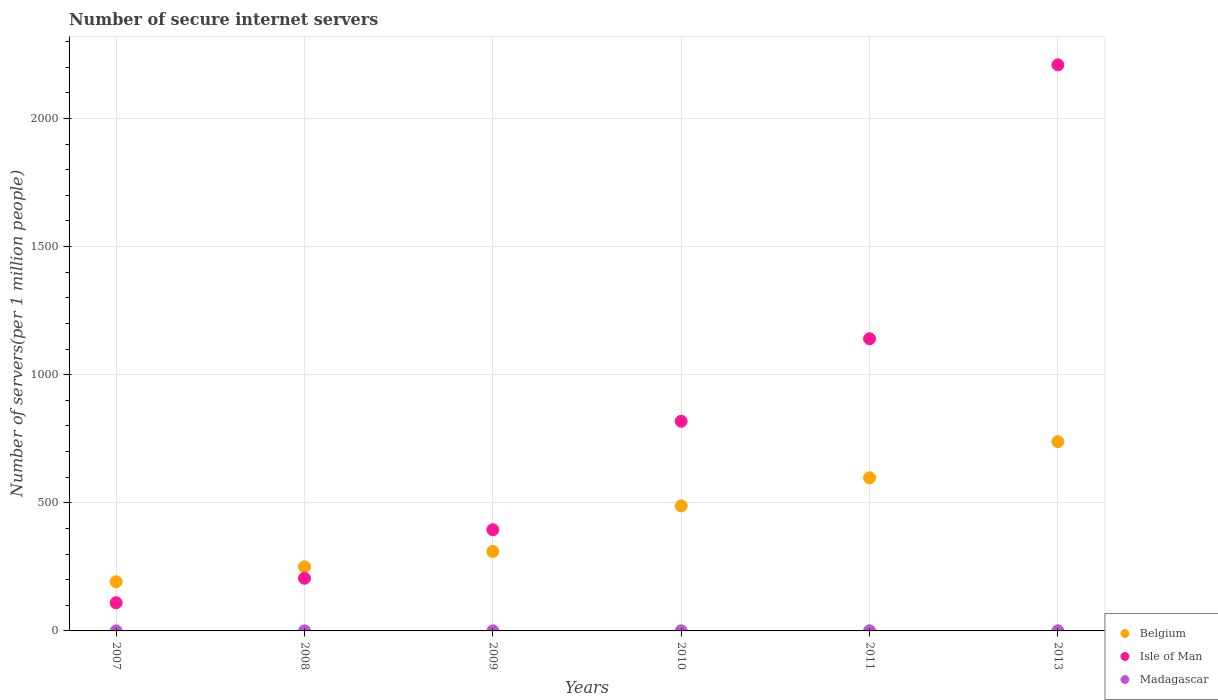Is the number of dotlines equal to the number of legend labels?
Your response must be concise. Yes. What is the number of secure internet servers in Belgium in 2011?
Provide a short and direct response. 597.41. Across all years, what is the maximum number of secure internet servers in Belgium?
Make the answer very short. 738.28. Across all years, what is the minimum number of secure internet servers in Madagascar?
Offer a terse response. 0.2. In which year was the number of secure internet servers in Belgium maximum?
Provide a succinct answer. 2013. What is the total number of secure internet servers in Isle of Man in the graph?
Keep it short and to the point. 4877.88. What is the difference between the number of secure internet servers in Belgium in 2007 and that in 2010?
Provide a succinct answer. -295.91. What is the difference between the number of secure internet servers in Madagascar in 2008 and the number of secure internet servers in Belgium in 2009?
Your answer should be compact. -309.9. What is the average number of secure internet servers in Isle of Man per year?
Give a very brief answer. 812.98. In the year 2008, what is the difference between the number of secure internet servers in Belgium and number of secure internet servers in Isle of Man?
Offer a terse response. 44.58. What is the ratio of the number of secure internet servers in Madagascar in 2008 to that in 2011?
Provide a short and direct response. 0.4. What is the difference between the highest and the second highest number of secure internet servers in Belgium?
Your answer should be very brief. 140.87. What is the difference between the highest and the lowest number of secure internet servers in Madagascar?
Make the answer very short. 0.45. Is the number of secure internet servers in Belgium strictly greater than the number of secure internet servers in Madagascar over the years?
Your response must be concise. Yes. What is the difference between two consecutive major ticks on the Y-axis?
Your answer should be compact. 500. Are the values on the major ticks of Y-axis written in scientific E-notation?
Your response must be concise. No. What is the title of the graph?
Offer a terse response. Number of secure internet servers. What is the label or title of the Y-axis?
Offer a terse response. Number of servers(per 1 million people). What is the Number of servers(per 1 million people) of Belgium in 2007?
Give a very brief answer. 192.08. What is the Number of servers(per 1 million people) in Isle of Man in 2007?
Your answer should be compact. 109.87. What is the Number of servers(per 1 million people) in Madagascar in 2007?
Offer a terse response. 0.21. What is the Number of servers(per 1 million people) of Belgium in 2008?
Offer a very short reply. 250.05. What is the Number of servers(per 1 million people) in Isle of Man in 2008?
Provide a short and direct response. 205.47. What is the Number of servers(per 1 million people) of Madagascar in 2008?
Your response must be concise. 0.2. What is the Number of servers(per 1 million people) in Belgium in 2009?
Give a very brief answer. 310.1. What is the Number of servers(per 1 million people) of Isle of Man in 2009?
Your answer should be very brief. 394.98. What is the Number of servers(per 1 million people) in Madagascar in 2009?
Make the answer very short. 0.39. What is the Number of servers(per 1 million people) in Belgium in 2010?
Your response must be concise. 487.99. What is the Number of servers(per 1 million people) in Isle of Man in 2010?
Your answer should be compact. 818.24. What is the Number of servers(per 1 million people) in Madagascar in 2010?
Your answer should be very brief. 0.47. What is the Number of servers(per 1 million people) in Belgium in 2011?
Your response must be concise. 597.41. What is the Number of servers(per 1 million people) in Isle of Man in 2011?
Keep it short and to the point. 1140.25. What is the Number of servers(per 1 million people) of Madagascar in 2011?
Your answer should be compact. 0.51. What is the Number of servers(per 1 million people) in Belgium in 2013?
Your answer should be compact. 738.28. What is the Number of servers(per 1 million people) in Isle of Man in 2013?
Ensure brevity in your answer.  2209.06. What is the Number of servers(per 1 million people) of Madagascar in 2013?
Your answer should be compact. 0.65. Across all years, what is the maximum Number of servers(per 1 million people) in Belgium?
Give a very brief answer. 738.28. Across all years, what is the maximum Number of servers(per 1 million people) in Isle of Man?
Your answer should be very brief. 2209.06. Across all years, what is the maximum Number of servers(per 1 million people) in Madagascar?
Provide a short and direct response. 0.65. Across all years, what is the minimum Number of servers(per 1 million people) in Belgium?
Provide a short and direct response. 192.08. Across all years, what is the minimum Number of servers(per 1 million people) in Isle of Man?
Offer a terse response. 109.87. Across all years, what is the minimum Number of servers(per 1 million people) in Madagascar?
Give a very brief answer. 0.2. What is the total Number of servers(per 1 million people) in Belgium in the graph?
Provide a short and direct response. 2575.9. What is the total Number of servers(per 1 million people) in Isle of Man in the graph?
Give a very brief answer. 4877.88. What is the total Number of servers(per 1 million people) of Madagascar in the graph?
Keep it short and to the point. 2.43. What is the difference between the Number of servers(per 1 million people) of Belgium in 2007 and that in 2008?
Your answer should be compact. -57.97. What is the difference between the Number of servers(per 1 million people) of Isle of Man in 2007 and that in 2008?
Offer a very short reply. -95.6. What is the difference between the Number of servers(per 1 million people) of Madagascar in 2007 and that in 2008?
Ensure brevity in your answer.  0.01. What is the difference between the Number of servers(per 1 million people) of Belgium in 2007 and that in 2009?
Your answer should be compact. -118.02. What is the difference between the Number of servers(per 1 million people) of Isle of Man in 2007 and that in 2009?
Give a very brief answer. -285.11. What is the difference between the Number of servers(per 1 million people) of Madagascar in 2007 and that in 2009?
Provide a short and direct response. -0.18. What is the difference between the Number of servers(per 1 million people) in Belgium in 2007 and that in 2010?
Provide a short and direct response. -295.91. What is the difference between the Number of servers(per 1 million people) in Isle of Man in 2007 and that in 2010?
Provide a short and direct response. -708.37. What is the difference between the Number of servers(per 1 million people) in Madagascar in 2007 and that in 2010?
Your answer should be compact. -0.27. What is the difference between the Number of servers(per 1 million people) of Belgium in 2007 and that in 2011?
Provide a succinct answer. -405.33. What is the difference between the Number of servers(per 1 million people) of Isle of Man in 2007 and that in 2011?
Make the answer very short. -1030.38. What is the difference between the Number of servers(per 1 million people) of Madagascar in 2007 and that in 2011?
Give a very brief answer. -0.3. What is the difference between the Number of servers(per 1 million people) of Belgium in 2007 and that in 2013?
Keep it short and to the point. -546.19. What is the difference between the Number of servers(per 1 million people) of Isle of Man in 2007 and that in 2013?
Give a very brief answer. -2099.19. What is the difference between the Number of servers(per 1 million people) of Madagascar in 2007 and that in 2013?
Provide a short and direct response. -0.45. What is the difference between the Number of servers(per 1 million people) of Belgium in 2008 and that in 2009?
Ensure brevity in your answer.  -60.05. What is the difference between the Number of servers(per 1 million people) of Isle of Man in 2008 and that in 2009?
Your response must be concise. -189.51. What is the difference between the Number of servers(per 1 million people) in Madagascar in 2008 and that in 2009?
Keep it short and to the point. -0.19. What is the difference between the Number of servers(per 1 million people) in Belgium in 2008 and that in 2010?
Provide a succinct answer. -237.94. What is the difference between the Number of servers(per 1 million people) of Isle of Man in 2008 and that in 2010?
Make the answer very short. -612.77. What is the difference between the Number of servers(per 1 million people) in Madagascar in 2008 and that in 2010?
Offer a very short reply. -0.27. What is the difference between the Number of servers(per 1 million people) of Belgium in 2008 and that in 2011?
Ensure brevity in your answer.  -347.36. What is the difference between the Number of servers(per 1 million people) in Isle of Man in 2008 and that in 2011?
Make the answer very short. -934.78. What is the difference between the Number of servers(per 1 million people) of Madagascar in 2008 and that in 2011?
Your answer should be very brief. -0.31. What is the difference between the Number of servers(per 1 million people) in Belgium in 2008 and that in 2013?
Your response must be concise. -488.23. What is the difference between the Number of servers(per 1 million people) in Isle of Man in 2008 and that in 2013?
Keep it short and to the point. -2003.59. What is the difference between the Number of servers(per 1 million people) of Madagascar in 2008 and that in 2013?
Your answer should be compact. -0.45. What is the difference between the Number of servers(per 1 million people) in Belgium in 2009 and that in 2010?
Provide a short and direct response. -177.89. What is the difference between the Number of servers(per 1 million people) in Isle of Man in 2009 and that in 2010?
Provide a short and direct response. -423.26. What is the difference between the Number of servers(per 1 million people) in Madagascar in 2009 and that in 2010?
Your response must be concise. -0.08. What is the difference between the Number of servers(per 1 million people) in Belgium in 2009 and that in 2011?
Offer a terse response. -287.31. What is the difference between the Number of servers(per 1 million people) in Isle of Man in 2009 and that in 2011?
Provide a succinct answer. -745.27. What is the difference between the Number of servers(per 1 million people) in Madagascar in 2009 and that in 2011?
Offer a terse response. -0.12. What is the difference between the Number of servers(per 1 million people) of Belgium in 2009 and that in 2013?
Your answer should be compact. -428.17. What is the difference between the Number of servers(per 1 million people) in Isle of Man in 2009 and that in 2013?
Keep it short and to the point. -1814.08. What is the difference between the Number of servers(per 1 million people) of Madagascar in 2009 and that in 2013?
Make the answer very short. -0.26. What is the difference between the Number of servers(per 1 million people) of Belgium in 2010 and that in 2011?
Give a very brief answer. -109.42. What is the difference between the Number of servers(per 1 million people) of Isle of Man in 2010 and that in 2011?
Offer a terse response. -322.01. What is the difference between the Number of servers(per 1 million people) in Madagascar in 2010 and that in 2011?
Provide a succinct answer. -0.03. What is the difference between the Number of servers(per 1 million people) in Belgium in 2010 and that in 2013?
Your response must be concise. -250.28. What is the difference between the Number of servers(per 1 million people) of Isle of Man in 2010 and that in 2013?
Provide a succinct answer. -1390.82. What is the difference between the Number of servers(per 1 million people) of Madagascar in 2010 and that in 2013?
Your response must be concise. -0.18. What is the difference between the Number of servers(per 1 million people) of Belgium in 2011 and that in 2013?
Offer a terse response. -140.87. What is the difference between the Number of servers(per 1 million people) of Isle of Man in 2011 and that in 2013?
Make the answer very short. -1068.81. What is the difference between the Number of servers(per 1 million people) of Madagascar in 2011 and that in 2013?
Provide a succinct answer. -0.15. What is the difference between the Number of servers(per 1 million people) in Belgium in 2007 and the Number of servers(per 1 million people) in Isle of Man in 2008?
Make the answer very short. -13.39. What is the difference between the Number of servers(per 1 million people) of Belgium in 2007 and the Number of servers(per 1 million people) of Madagascar in 2008?
Make the answer very short. 191.88. What is the difference between the Number of servers(per 1 million people) of Isle of Man in 2007 and the Number of servers(per 1 million people) of Madagascar in 2008?
Keep it short and to the point. 109.67. What is the difference between the Number of servers(per 1 million people) of Belgium in 2007 and the Number of servers(per 1 million people) of Isle of Man in 2009?
Offer a very short reply. -202.9. What is the difference between the Number of servers(per 1 million people) of Belgium in 2007 and the Number of servers(per 1 million people) of Madagascar in 2009?
Keep it short and to the point. 191.69. What is the difference between the Number of servers(per 1 million people) in Isle of Man in 2007 and the Number of servers(per 1 million people) in Madagascar in 2009?
Provide a short and direct response. 109.48. What is the difference between the Number of servers(per 1 million people) of Belgium in 2007 and the Number of servers(per 1 million people) of Isle of Man in 2010?
Provide a short and direct response. -626.16. What is the difference between the Number of servers(per 1 million people) of Belgium in 2007 and the Number of servers(per 1 million people) of Madagascar in 2010?
Your response must be concise. 191.61. What is the difference between the Number of servers(per 1 million people) of Isle of Man in 2007 and the Number of servers(per 1 million people) of Madagascar in 2010?
Offer a very short reply. 109.4. What is the difference between the Number of servers(per 1 million people) of Belgium in 2007 and the Number of servers(per 1 million people) of Isle of Man in 2011?
Offer a terse response. -948.17. What is the difference between the Number of servers(per 1 million people) of Belgium in 2007 and the Number of servers(per 1 million people) of Madagascar in 2011?
Provide a succinct answer. 191.57. What is the difference between the Number of servers(per 1 million people) of Isle of Man in 2007 and the Number of servers(per 1 million people) of Madagascar in 2011?
Offer a terse response. 109.36. What is the difference between the Number of servers(per 1 million people) in Belgium in 2007 and the Number of servers(per 1 million people) in Isle of Man in 2013?
Provide a succinct answer. -2016.98. What is the difference between the Number of servers(per 1 million people) in Belgium in 2007 and the Number of servers(per 1 million people) in Madagascar in 2013?
Provide a short and direct response. 191.43. What is the difference between the Number of servers(per 1 million people) in Isle of Man in 2007 and the Number of servers(per 1 million people) in Madagascar in 2013?
Your answer should be compact. 109.22. What is the difference between the Number of servers(per 1 million people) in Belgium in 2008 and the Number of servers(per 1 million people) in Isle of Man in 2009?
Your answer should be very brief. -144.94. What is the difference between the Number of servers(per 1 million people) of Belgium in 2008 and the Number of servers(per 1 million people) of Madagascar in 2009?
Your response must be concise. 249.66. What is the difference between the Number of servers(per 1 million people) in Isle of Man in 2008 and the Number of servers(per 1 million people) in Madagascar in 2009?
Ensure brevity in your answer.  205.08. What is the difference between the Number of servers(per 1 million people) in Belgium in 2008 and the Number of servers(per 1 million people) in Isle of Man in 2010?
Your answer should be very brief. -568.2. What is the difference between the Number of servers(per 1 million people) of Belgium in 2008 and the Number of servers(per 1 million people) of Madagascar in 2010?
Give a very brief answer. 249.57. What is the difference between the Number of servers(per 1 million people) in Isle of Man in 2008 and the Number of servers(per 1 million people) in Madagascar in 2010?
Offer a very short reply. 205. What is the difference between the Number of servers(per 1 million people) in Belgium in 2008 and the Number of servers(per 1 million people) in Isle of Man in 2011?
Your answer should be compact. -890.2. What is the difference between the Number of servers(per 1 million people) of Belgium in 2008 and the Number of servers(per 1 million people) of Madagascar in 2011?
Your answer should be very brief. 249.54. What is the difference between the Number of servers(per 1 million people) in Isle of Man in 2008 and the Number of servers(per 1 million people) in Madagascar in 2011?
Provide a succinct answer. 204.96. What is the difference between the Number of servers(per 1 million people) of Belgium in 2008 and the Number of servers(per 1 million people) of Isle of Man in 2013?
Provide a short and direct response. -1959.02. What is the difference between the Number of servers(per 1 million people) of Belgium in 2008 and the Number of servers(per 1 million people) of Madagascar in 2013?
Offer a very short reply. 249.39. What is the difference between the Number of servers(per 1 million people) in Isle of Man in 2008 and the Number of servers(per 1 million people) in Madagascar in 2013?
Ensure brevity in your answer.  204.82. What is the difference between the Number of servers(per 1 million people) in Belgium in 2009 and the Number of servers(per 1 million people) in Isle of Man in 2010?
Offer a terse response. -508.14. What is the difference between the Number of servers(per 1 million people) of Belgium in 2009 and the Number of servers(per 1 million people) of Madagascar in 2010?
Offer a very short reply. 309.63. What is the difference between the Number of servers(per 1 million people) of Isle of Man in 2009 and the Number of servers(per 1 million people) of Madagascar in 2010?
Keep it short and to the point. 394.51. What is the difference between the Number of servers(per 1 million people) in Belgium in 2009 and the Number of servers(per 1 million people) in Isle of Man in 2011?
Your response must be concise. -830.15. What is the difference between the Number of servers(per 1 million people) of Belgium in 2009 and the Number of servers(per 1 million people) of Madagascar in 2011?
Ensure brevity in your answer.  309.59. What is the difference between the Number of servers(per 1 million people) in Isle of Man in 2009 and the Number of servers(per 1 million people) in Madagascar in 2011?
Your answer should be compact. 394.48. What is the difference between the Number of servers(per 1 million people) in Belgium in 2009 and the Number of servers(per 1 million people) in Isle of Man in 2013?
Provide a succinct answer. -1898.96. What is the difference between the Number of servers(per 1 million people) of Belgium in 2009 and the Number of servers(per 1 million people) of Madagascar in 2013?
Ensure brevity in your answer.  309.45. What is the difference between the Number of servers(per 1 million people) in Isle of Man in 2009 and the Number of servers(per 1 million people) in Madagascar in 2013?
Provide a succinct answer. 394.33. What is the difference between the Number of servers(per 1 million people) in Belgium in 2010 and the Number of servers(per 1 million people) in Isle of Man in 2011?
Your answer should be compact. -652.26. What is the difference between the Number of servers(per 1 million people) of Belgium in 2010 and the Number of servers(per 1 million people) of Madagascar in 2011?
Give a very brief answer. 487.48. What is the difference between the Number of servers(per 1 million people) of Isle of Man in 2010 and the Number of servers(per 1 million people) of Madagascar in 2011?
Your answer should be very brief. 817.74. What is the difference between the Number of servers(per 1 million people) of Belgium in 2010 and the Number of servers(per 1 million people) of Isle of Man in 2013?
Make the answer very short. -1721.07. What is the difference between the Number of servers(per 1 million people) in Belgium in 2010 and the Number of servers(per 1 million people) in Madagascar in 2013?
Give a very brief answer. 487.34. What is the difference between the Number of servers(per 1 million people) in Isle of Man in 2010 and the Number of servers(per 1 million people) in Madagascar in 2013?
Your answer should be very brief. 817.59. What is the difference between the Number of servers(per 1 million people) of Belgium in 2011 and the Number of servers(per 1 million people) of Isle of Man in 2013?
Your answer should be very brief. -1611.66. What is the difference between the Number of servers(per 1 million people) in Belgium in 2011 and the Number of servers(per 1 million people) in Madagascar in 2013?
Offer a very short reply. 596.75. What is the difference between the Number of servers(per 1 million people) in Isle of Man in 2011 and the Number of servers(per 1 million people) in Madagascar in 2013?
Keep it short and to the point. 1139.6. What is the average Number of servers(per 1 million people) in Belgium per year?
Offer a very short reply. 429.32. What is the average Number of servers(per 1 million people) in Isle of Man per year?
Provide a short and direct response. 812.98. What is the average Number of servers(per 1 million people) in Madagascar per year?
Provide a short and direct response. 0.41. In the year 2007, what is the difference between the Number of servers(per 1 million people) of Belgium and Number of servers(per 1 million people) of Isle of Man?
Give a very brief answer. 82.21. In the year 2007, what is the difference between the Number of servers(per 1 million people) in Belgium and Number of servers(per 1 million people) in Madagascar?
Your response must be concise. 191.88. In the year 2007, what is the difference between the Number of servers(per 1 million people) in Isle of Man and Number of servers(per 1 million people) in Madagascar?
Offer a very short reply. 109.66. In the year 2008, what is the difference between the Number of servers(per 1 million people) of Belgium and Number of servers(per 1 million people) of Isle of Man?
Provide a succinct answer. 44.58. In the year 2008, what is the difference between the Number of servers(per 1 million people) in Belgium and Number of servers(per 1 million people) in Madagascar?
Provide a succinct answer. 249.85. In the year 2008, what is the difference between the Number of servers(per 1 million people) of Isle of Man and Number of servers(per 1 million people) of Madagascar?
Offer a terse response. 205.27. In the year 2009, what is the difference between the Number of servers(per 1 million people) in Belgium and Number of servers(per 1 million people) in Isle of Man?
Your answer should be compact. -84.88. In the year 2009, what is the difference between the Number of servers(per 1 million people) of Belgium and Number of servers(per 1 million people) of Madagascar?
Keep it short and to the point. 309.71. In the year 2009, what is the difference between the Number of servers(per 1 million people) of Isle of Man and Number of servers(per 1 million people) of Madagascar?
Ensure brevity in your answer.  394.59. In the year 2010, what is the difference between the Number of servers(per 1 million people) in Belgium and Number of servers(per 1 million people) in Isle of Man?
Give a very brief answer. -330.25. In the year 2010, what is the difference between the Number of servers(per 1 million people) of Belgium and Number of servers(per 1 million people) of Madagascar?
Give a very brief answer. 487.52. In the year 2010, what is the difference between the Number of servers(per 1 million people) of Isle of Man and Number of servers(per 1 million people) of Madagascar?
Offer a very short reply. 817.77. In the year 2011, what is the difference between the Number of servers(per 1 million people) of Belgium and Number of servers(per 1 million people) of Isle of Man?
Provide a succinct answer. -542.84. In the year 2011, what is the difference between the Number of servers(per 1 million people) of Belgium and Number of servers(per 1 million people) of Madagascar?
Your answer should be compact. 596.9. In the year 2011, what is the difference between the Number of servers(per 1 million people) of Isle of Man and Number of servers(per 1 million people) of Madagascar?
Offer a very short reply. 1139.74. In the year 2013, what is the difference between the Number of servers(per 1 million people) in Belgium and Number of servers(per 1 million people) in Isle of Man?
Keep it short and to the point. -1470.79. In the year 2013, what is the difference between the Number of servers(per 1 million people) in Belgium and Number of servers(per 1 million people) in Madagascar?
Your answer should be compact. 737.62. In the year 2013, what is the difference between the Number of servers(per 1 million people) in Isle of Man and Number of servers(per 1 million people) in Madagascar?
Offer a terse response. 2208.41. What is the ratio of the Number of servers(per 1 million people) in Belgium in 2007 to that in 2008?
Offer a very short reply. 0.77. What is the ratio of the Number of servers(per 1 million people) of Isle of Man in 2007 to that in 2008?
Provide a succinct answer. 0.53. What is the ratio of the Number of servers(per 1 million people) in Madagascar in 2007 to that in 2008?
Make the answer very short. 1.03. What is the ratio of the Number of servers(per 1 million people) in Belgium in 2007 to that in 2009?
Offer a very short reply. 0.62. What is the ratio of the Number of servers(per 1 million people) of Isle of Man in 2007 to that in 2009?
Keep it short and to the point. 0.28. What is the ratio of the Number of servers(per 1 million people) of Madagascar in 2007 to that in 2009?
Your answer should be very brief. 0.53. What is the ratio of the Number of servers(per 1 million people) in Belgium in 2007 to that in 2010?
Your response must be concise. 0.39. What is the ratio of the Number of servers(per 1 million people) of Isle of Man in 2007 to that in 2010?
Offer a terse response. 0.13. What is the ratio of the Number of servers(per 1 million people) of Madagascar in 2007 to that in 2010?
Your response must be concise. 0.44. What is the ratio of the Number of servers(per 1 million people) of Belgium in 2007 to that in 2011?
Offer a terse response. 0.32. What is the ratio of the Number of servers(per 1 million people) of Isle of Man in 2007 to that in 2011?
Your answer should be very brief. 0.1. What is the ratio of the Number of servers(per 1 million people) of Madagascar in 2007 to that in 2011?
Provide a succinct answer. 0.41. What is the ratio of the Number of servers(per 1 million people) of Belgium in 2007 to that in 2013?
Your response must be concise. 0.26. What is the ratio of the Number of servers(per 1 million people) in Isle of Man in 2007 to that in 2013?
Your answer should be very brief. 0.05. What is the ratio of the Number of servers(per 1 million people) of Madagascar in 2007 to that in 2013?
Provide a succinct answer. 0.32. What is the ratio of the Number of servers(per 1 million people) of Belgium in 2008 to that in 2009?
Your answer should be very brief. 0.81. What is the ratio of the Number of servers(per 1 million people) of Isle of Man in 2008 to that in 2009?
Ensure brevity in your answer.  0.52. What is the ratio of the Number of servers(per 1 million people) of Madagascar in 2008 to that in 2009?
Your answer should be very brief. 0.51. What is the ratio of the Number of servers(per 1 million people) in Belgium in 2008 to that in 2010?
Ensure brevity in your answer.  0.51. What is the ratio of the Number of servers(per 1 million people) in Isle of Man in 2008 to that in 2010?
Your response must be concise. 0.25. What is the ratio of the Number of servers(per 1 million people) of Madagascar in 2008 to that in 2010?
Provide a short and direct response. 0.42. What is the ratio of the Number of servers(per 1 million people) in Belgium in 2008 to that in 2011?
Provide a succinct answer. 0.42. What is the ratio of the Number of servers(per 1 million people) in Isle of Man in 2008 to that in 2011?
Provide a short and direct response. 0.18. What is the ratio of the Number of servers(per 1 million people) of Madagascar in 2008 to that in 2011?
Provide a succinct answer. 0.4. What is the ratio of the Number of servers(per 1 million people) of Belgium in 2008 to that in 2013?
Ensure brevity in your answer.  0.34. What is the ratio of the Number of servers(per 1 million people) of Isle of Man in 2008 to that in 2013?
Keep it short and to the point. 0.09. What is the ratio of the Number of servers(per 1 million people) in Madagascar in 2008 to that in 2013?
Offer a very short reply. 0.31. What is the ratio of the Number of servers(per 1 million people) of Belgium in 2009 to that in 2010?
Keep it short and to the point. 0.64. What is the ratio of the Number of servers(per 1 million people) of Isle of Man in 2009 to that in 2010?
Offer a very short reply. 0.48. What is the ratio of the Number of servers(per 1 million people) of Madagascar in 2009 to that in 2010?
Offer a very short reply. 0.82. What is the ratio of the Number of servers(per 1 million people) of Belgium in 2009 to that in 2011?
Give a very brief answer. 0.52. What is the ratio of the Number of servers(per 1 million people) of Isle of Man in 2009 to that in 2011?
Your answer should be very brief. 0.35. What is the ratio of the Number of servers(per 1 million people) in Madagascar in 2009 to that in 2011?
Offer a terse response. 0.77. What is the ratio of the Number of servers(per 1 million people) in Belgium in 2009 to that in 2013?
Make the answer very short. 0.42. What is the ratio of the Number of servers(per 1 million people) in Isle of Man in 2009 to that in 2013?
Keep it short and to the point. 0.18. What is the ratio of the Number of servers(per 1 million people) of Madagascar in 2009 to that in 2013?
Your response must be concise. 0.6. What is the ratio of the Number of servers(per 1 million people) of Belgium in 2010 to that in 2011?
Make the answer very short. 0.82. What is the ratio of the Number of servers(per 1 million people) in Isle of Man in 2010 to that in 2011?
Offer a very short reply. 0.72. What is the ratio of the Number of servers(per 1 million people) of Madagascar in 2010 to that in 2011?
Keep it short and to the point. 0.93. What is the ratio of the Number of servers(per 1 million people) of Belgium in 2010 to that in 2013?
Provide a short and direct response. 0.66. What is the ratio of the Number of servers(per 1 million people) of Isle of Man in 2010 to that in 2013?
Keep it short and to the point. 0.37. What is the ratio of the Number of servers(per 1 million people) in Madagascar in 2010 to that in 2013?
Your response must be concise. 0.72. What is the ratio of the Number of servers(per 1 million people) in Belgium in 2011 to that in 2013?
Offer a terse response. 0.81. What is the ratio of the Number of servers(per 1 million people) of Isle of Man in 2011 to that in 2013?
Your response must be concise. 0.52. What is the ratio of the Number of servers(per 1 million people) in Madagascar in 2011 to that in 2013?
Offer a very short reply. 0.78. What is the difference between the highest and the second highest Number of servers(per 1 million people) in Belgium?
Ensure brevity in your answer.  140.87. What is the difference between the highest and the second highest Number of servers(per 1 million people) of Isle of Man?
Offer a very short reply. 1068.81. What is the difference between the highest and the second highest Number of servers(per 1 million people) in Madagascar?
Provide a succinct answer. 0.15. What is the difference between the highest and the lowest Number of servers(per 1 million people) of Belgium?
Offer a terse response. 546.19. What is the difference between the highest and the lowest Number of servers(per 1 million people) of Isle of Man?
Ensure brevity in your answer.  2099.19. What is the difference between the highest and the lowest Number of servers(per 1 million people) of Madagascar?
Your answer should be very brief. 0.45. 